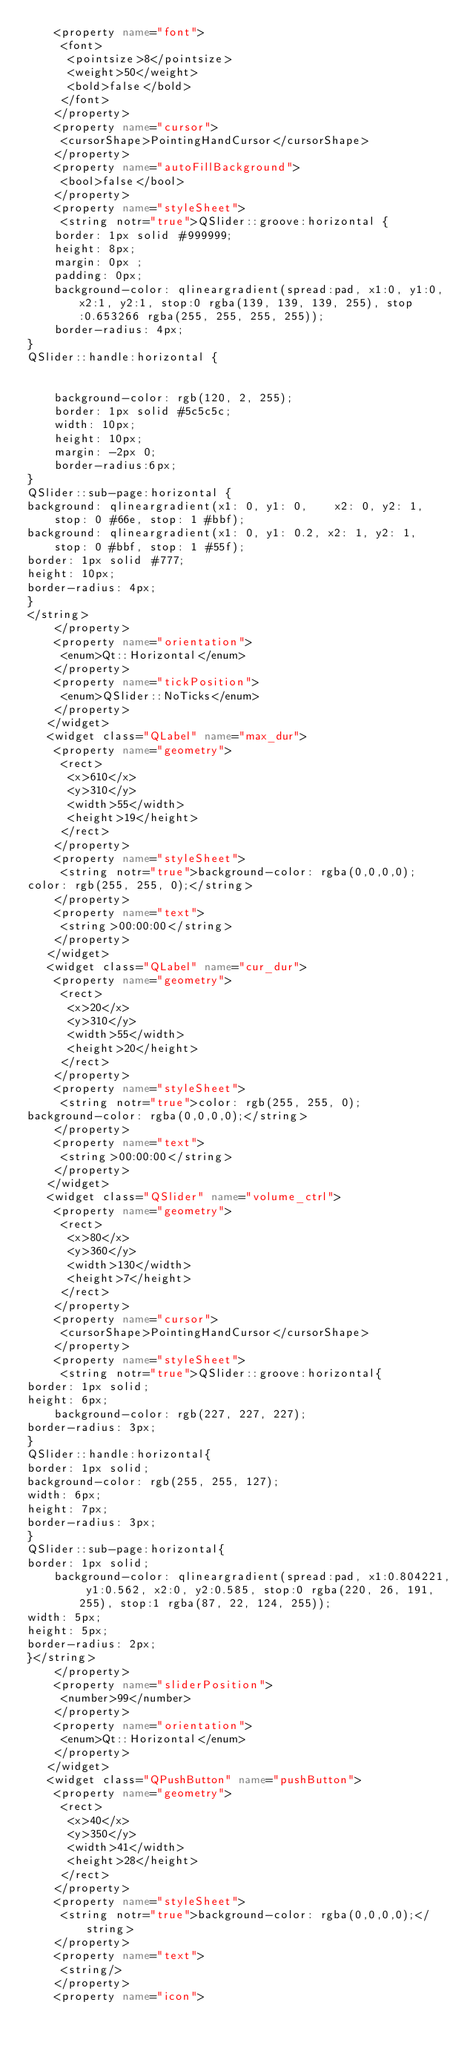<code> <loc_0><loc_0><loc_500><loc_500><_XML_>    <property name="font">
     <font>
      <pointsize>8</pointsize>
      <weight>50</weight>
      <bold>false</bold>
     </font>
    </property>
    <property name="cursor">
     <cursorShape>PointingHandCursor</cursorShape>
    </property>
    <property name="autoFillBackground">
     <bool>false</bool>
    </property>
    <property name="styleSheet">
     <string notr="true">QSlider::groove:horizontal {
	border: 1px solid #999999;
    height: 8px;
    margin: 0px ;
	padding: 0px;
	background-color: qlineargradient(spread:pad, x1:0, y1:0, x2:1, y2:1, stop:0 rgba(139, 139, 139, 255), stop:0.653266 rgba(255, 255, 255, 255));
	border-radius: 4px;
}
QSlider::handle:horizontal {
	
	
	background-color: rgb(120, 2, 255);
    border: 1px solid #5c5c5c;
    width: 10px;
	height: 10px;
    margin: -2px 0;
    border-radius:6px;
}
QSlider::sub-page:horizontal {
background: qlineargradient(x1: 0, y1: 0,    x2: 0, y2: 1,
    stop: 0 #66e, stop: 1 #bbf);
background: qlineargradient(x1: 0, y1: 0.2, x2: 1, y2: 1,
    stop: 0 #bbf, stop: 1 #55f);
border: 1px solid #777;
height: 10px;
border-radius: 4px;
}
</string>
    </property>
    <property name="orientation">
     <enum>Qt::Horizontal</enum>
    </property>
    <property name="tickPosition">
     <enum>QSlider::NoTicks</enum>
    </property>
   </widget>
   <widget class="QLabel" name="max_dur">
    <property name="geometry">
     <rect>
      <x>610</x>
      <y>310</y>
      <width>55</width>
      <height>19</height>
     </rect>
    </property>
    <property name="styleSheet">
     <string notr="true">background-color: rgba(0,0,0,0);
color: rgb(255, 255, 0);</string>
    </property>
    <property name="text">
     <string>00:00:00</string>
    </property>
   </widget>
   <widget class="QLabel" name="cur_dur">
    <property name="geometry">
     <rect>
      <x>20</x>
      <y>310</y>
      <width>55</width>
      <height>20</height>
     </rect>
    </property>
    <property name="styleSheet">
     <string notr="true">color: rgb(255, 255, 0);
background-color: rgba(0,0,0,0);</string>
    </property>
    <property name="text">
     <string>00:00:00</string>
    </property>
   </widget>
   <widget class="QSlider" name="volume_ctrl">
    <property name="geometry">
     <rect>
      <x>80</x>
      <y>360</y>
      <width>130</width>
      <height>7</height>
     </rect>
    </property>
    <property name="cursor">
     <cursorShape>PointingHandCursor</cursorShape>
    </property>
    <property name="styleSheet">
     <string notr="true">QSlider::groove:horizontal{
border: 1px solid;
height: 6px;
	background-color: rgb(227, 227, 227);
border-radius: 3px;
}
QSlider::handle:horizontal{
border: 1px solid;
background-color: rgb(255, 255, 127);
width: 6px;
height: 7px;
border-radius: 3px;
}
QSlider::sub-page:horizontal{
border: 1px solid;
	background-color: qlineargradient(spread:pad, x1:0.804221, y1:0.562, x2:0, y2:0.585, stop:0 rgba(220, 26, 191, 255), stop:1 rgba(87, 22, 124, 255));
width: 5px;
height: 5px;
border-radius: 2px;
}</string>
    </property>
    <property name="sliderPosition">
     <number>99</number>
    </property>
    <property name="orientation">
     <enum>Qt::Horizontal</enum>
    </property>
   </widget>
   <widget class="QPushButton" name="pushButton">
    <property name="geometry">
     <rect>
      <x>40</x>
      <y>350</y>
      <width>41</width>
      <height>28</height>
     </rect>
    </property>
    <property name="styleSheet">
     <string notr="true">background-color: rgba(0,0,0,0);</string>
    </property>
    <property name="text">
     <string/>
    </property>
    <property name="icon"></code> 